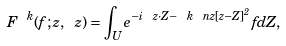<formula> <loc_0><loc_0><loc_500><loc_500>F ^ { \ k } ( f ; z , \ z ) = \int _ { U } e ^ { - i \ z \cdot Z - \ k \ n z [ z - Z ] ^ { 2 } } f d Z ,</formula> 